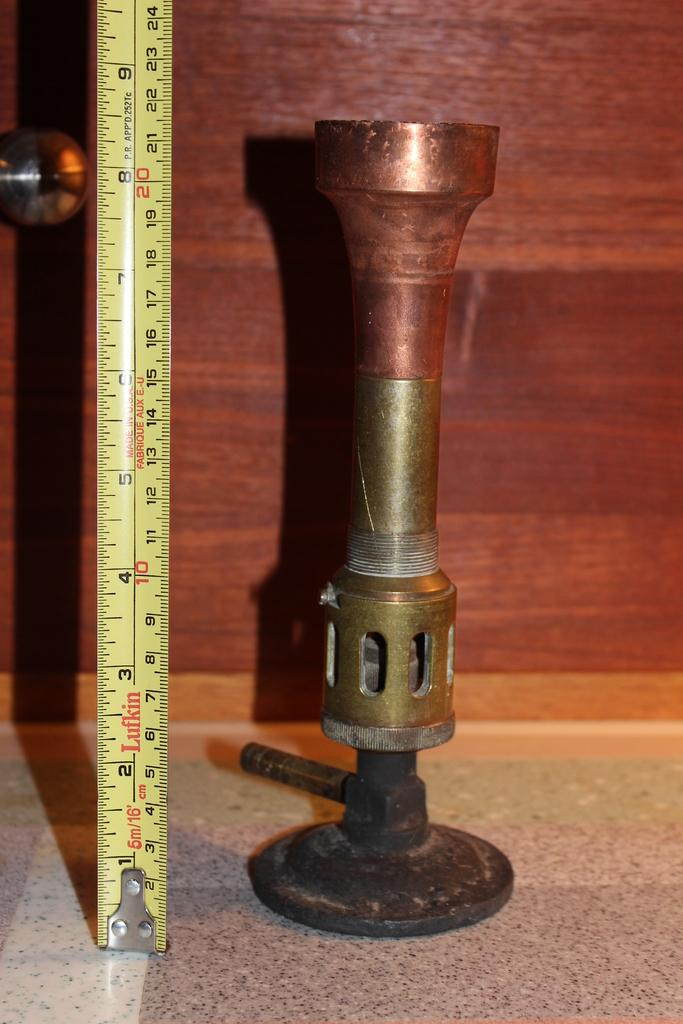<image>
Present a compact description of the photo's key features. A copper piece of hardware standing next to a tape measure showing 8 and a half inches. 